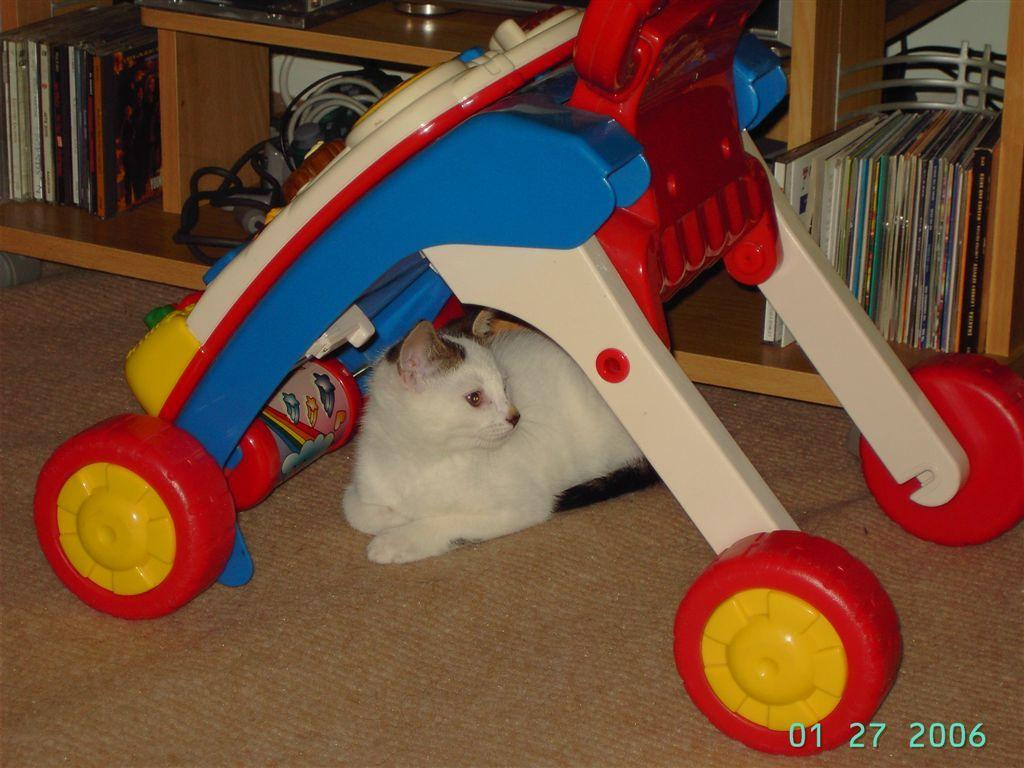What type of animal is present in the image? There is a cat in the image. What is the cat's position in relation to the babysitter? The cat is under a babysitter in the image. What can be seen in the background of the image? There is a bookshelf in the background of the image. What type of rhythm is the cat playing on the guitar in the image? There is no guitar or rhythm present in the image; it features a cat under a babysitter and a bookshelf in the background. 